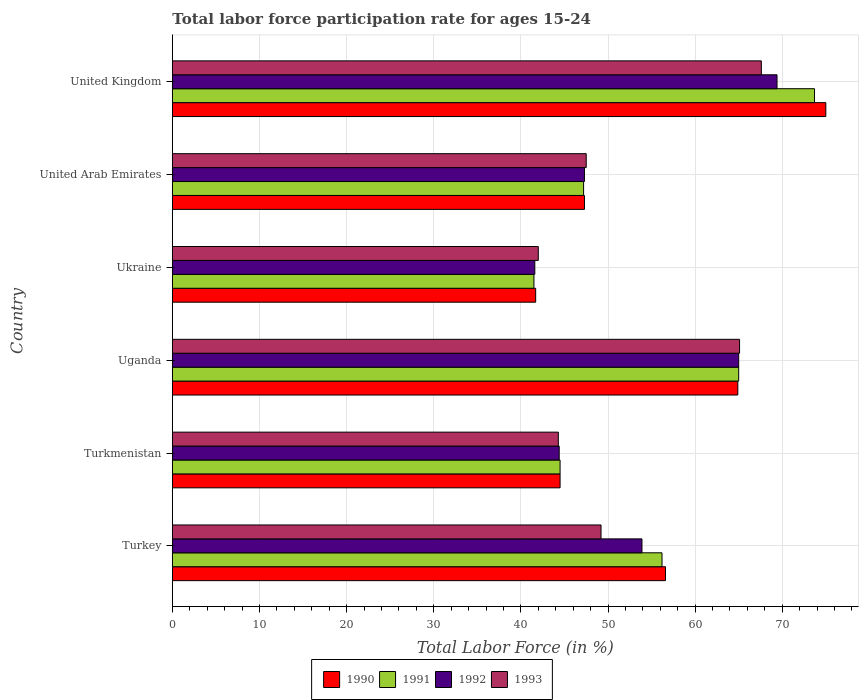How many groups of bars are there?
Your answer should be very brief. 6. Are the number of bars per tick equal to the number of legend labels?
Offer a terse response. Yes. Are the number of bars on each tick of the Y-axis equal?
Offer a terse response. Yes. What is the label of the 4th group of bars from the top?
Offer a very short reply. Uganda. What is the labor force participation rate in 1991 in United Kingdom?
Your answer should be compact. 73.7. Across all countries, what is the maximum labor force participation rate in 1990?
Your answer should be compact. 75. Across all countries, what is the minimum labor force participation rate in 1990?
Offer a very short reply. 41.7. In which country was the labor force participation rate in 1991 maximum?
Your answer should be very brief. United Kingdom. In which country was the labor force participation rate in 1993 minimum?
Your answer should be compact. Ukraine. What is the total labor force participation rate in 1990 in the graph?
Make the answer very short. 330. What is the difference between the labor force participation rate in 1993 in United Arab Emirates and that in United Kingdom?
Provide a succinct answer. -20.1. What is the difference between the labor force participation rate in 1991 in Ukraine and the labor force participation rate in 1992 in Turkey?
Give a very brief answer. -12.4. What is the average labor force participation rate in 1992 per country?
Offer a very short reply. 53.6. What is the difference between the labor force participation rate in 1991 and labor force participation rate in 1993 in Turkey?
Keep it short and to the point. 7. What is the ratio of the labor force participation rate in 1992 in Turkey to that in Turkmenistan?
Your answer should be very brief. 1.21. Is the labor force participation rate in 1992 in Turkmenistan less than that in United Arab Emirates?
Provide a short and direct response. Yes. What is the difference between the highest and the second highest labor force participation rate in 1992?
Make the answer very short. 4.4. What is the difference between the highest and the lowest labor force participation rate in 1991?
Make the answer very short. 32.2. Is the sum of the labor force participation rate in 1991 in Turkey and Turkmenistan greater than the maximum labor force participation rate in 1992 across all countries?
Your response must be concise. Yes. Is it the case that in every country, the sum of the labor force participation rate in 1990 and labor force participation rate in 1992 is greater than the sum of labor force participation rate in 1991 and labor force participation rate in 1993?
Your answer should be compact. No. Are all the bars in the graph horizontal?
Offer a very short reply. Yes. How many countries are there in the graph?
Give a very brief answer. 6. Are the values on the major ticks of X-axis written in scientific E-notation?
Ensure brevity in your answer.  No. Does the graph contain any zero values?
Ensure brevity in your answer.  No. Does the graph contain grids?
Give a very brief answer. Yes. How many legend labels are there?
Keep it short and to the point. 4. What is the title of the graph?
Your response must be concise. Total labor force participation rate for ages 15-24. What is the label or title of the X-axis?
Your answer should be compact. Total Labor Force (in %). What is the label or title of the Y-axis?
Your answer should be very brief. Country. What is the Total Labor Force (in %) in 1990 in Turkey?
Keep it short and to the point. 56.6. What is the Total Labor Force (in %) of 1991 in Turkey?
Keep it short and to the point. 56.2. What is the Total Labor Force (in %) in 1992 in Turkey?
Offer a very short reply. 53.9. What is the Total Labor Force (in %) in 1993 in Turkey?
Provide a short and direct response. 49.2. What is the Total Labor Force (in %) in 1990 in Turkmenistan?
Make the answer very short. 44.5. What is the Total Labor Force (in %) in 1991 in Turkmenistan?
Provide a short and direct response. 44.5. What is the Total Labor Force (in %) of 1992 in Turkmenistan?
Make the answer very short. 44.4. What is the Total Labor Force (in %) in 1993 in Turkmenistan?
Your answer should be very brief. 44.3. What is the Total Labor Force (in %) of 1990 in Uganda?
Offer a very short reply. 64.9. What is the Total Labor Force (in %) of 1993 in Uganda?
Your answer should be compact. 65.1. What is the Total Labor Force (in %) in 1990 in Ukraine?
Your response must be concise. 41.7. What is the Total Labor Force (in %) of 1991 in Ukraine?
Your answer should be very brief. 41.5. What is the Total Labor Force (in %) of 1992 in Ukraine?
Ensure brevity in your answer.  41.6. What is the Total Labor Force (in %) of 1990 in United Arab Emirates?
Your answer should be compact. 47.3. What is the Total Labor Force (in %) in 1991 in United Arab Emirates?
Offer a very short reply. 47.2. What is the Total Labor Force (in %) in 1992 in United Arab Emirates?
Keep it short and to the point. 47.3. What is the Total Labor Force (in %) in 1993 in United Arab Emirates?
Ensure brevity in your answer.  47.5. What is the Total Labor Force (in %) of 1990 in United Kingdom?
Keep it short and to the point. 75. What is the Total Labor Force (in %) of 1991 in United Kingdom?
Your response must be concise. 73.7. What is the Total Labor Force (in %) of 1992 in United Kingdom?
Provide a succinct answer. 69.4. What is the Total Labor Force (in %) in 1993 in United Kingdom?
Your answer should be very brief. 67.6. Across all countries, what is the maximum Total Labor Force (in %) in 1990?
Make the answer very short. 75. Across all countries, what is the maximum Total Labor Force (in %) of 1991?
Your answer should be compact. 73.7. Across all countries, what is the maximum Total Labor Force (in %) in 1992?
Keep it short and to the point. 69.4. Across all countries, what is the maximum Total Labor Force (in %) of 1993?
Keep it short and to the point. 67.6. Across all countries, what is the minimum Total Labor Force (in %) of 1990?
Provide a succinct answer. 41.7. Across all countries, what is the minimum Total Labor Force (in %) of 1991?
Provide a short and direct response. 41.5. Across all countries, what is the minimum Total Labor Force (in %) in 1992?
Offer a terse response. 41.6. Across all countries, what is the minimum Total Labor Force (in %) in 1993?
Offer a very short reply. 42. What is the total Total Labor Force (in %) of 1990 in the graph?
Your answer should be very brief. 330. What is the total Total Labor Force (in %) of 1991 in the graph?
Ensure brevity in your answer.  328.1. What is the total Total Labor Force (in %) of 1992 in the graph?
Your response must be concise. 321.6. What is the total Total Labor Force (in %) in 1993 in the graph?
Offer a terse response. 315.7. What is the difference between the Total Labor Force (in %) in 1990 in Turkey and that in Turkmenistan?
Keep it short and to the point. 12.1. What is the difference between the Total Labor Force (in %) in 1992 in Turkey and that in Turkmenistan?
Offer a very short reply. 9.5. What is the difference between the Total Labor Force (in %) of 1990 in Turkey and that in Uganda?
Offer a terse response. -8.3. What is the difference between the Total Labor Force (in %) of 1991 in Turkey and that in Uganda?
Give a very brief answer. -8.8. What is the difference between the Total Labor Force (in %) of 1993 in Turkey and that in Uganda?
Offer a terse response. -15.9. What is the difference between the Total Labor Force (in %) in 1990 in Turkey and that in Ukraine?
Offer a very short reply. 14.9. What is the difference between the Total Labor Force (in %) of 1990 in Turkey and that in United Arab Emirates?
Your answer should be very brief. 9.3. What is the difference between the Total Labor Force (in %) of 1991 in Turkey and that in United Arab Emirates?
Give a very brief answer. 9. What is the difference between the Total Labor Force (in %) of 1992 in Turkey and that in United Arab Emirates?
Keep it short and to the point. 6.6. What is the difference between the Total Labor Force (in %) of 1990 in Turkey and that in United Kingdom?
Give a very brief answer. -18.4. What is the difference between the Total Labor Force (in %) in 1991 in Turkey and that in United Kingdom?
Offer a terse response. -17.5. What is the difference between the Total Labor Force (in %) in 1992 in Turkey and that in United Kingdom?
Provide a succinct answer. -15.5. What is the difference between the Total Labor Force (in %) in 1993 in Turkey and that in United Kingdom?
Ensure brevity in your answer.  -18.4. What is the difference between the Total Labor Force (in %) of 1990 in Turkmenistan and that in Uganda?
Make the answer very short. -20.4. What is the difference between the Total Labor Force (in %) of 1991 in Turkmenistan and that in Uganda?
Your answer should be very brief. -20.5. What is the difference between the Total Labor Force (in %) of 1992 in Turkmenistan and that in Uganda?
Make the answer very short. -20.6. What is the difference between the Total Labor Force (in %) in 1993 in Turkmenistan and that in Uganda?
Offer a very short reply. -20.8. What is the difference between the Total Labor Force (in %) in 1990 in Turkmenistan and that in Ukraine?
Offer a terse response. 2.8. What is the difference between the Total Labor Force (in %) in 1991 in Turkmenistan and that in Ukraine?
Your answer should be compact. 3. What is the difference between the Total Labor Force (in %) of 1993 in Turkmenistan and that in Ukraine?
Keep it short and to the point. 2.3. What is the difference between the Total Labor Force (in %) of 1991 in Turkmenistan and that in United Arab Emirates?
Make the answer very short. -2.7. What is the difference between the Total Labor Force (in %) in 1992 in Turkmenistan and that in United Arab Emirates?
Give a very brief answer. -2.9. What is the difference between the Total Labor Force (in %) of 1990 in Turkmenistan and that in United Kingdom?
Make the answer very short. -30.5. What is the difference between the Total Labor Force (in %) of 1991 in Turkmenistan and that in United Kingdom?
Give a very brief answer. -29.2. What is the difference between the Total Labor Force (in %) in 1992 in Turkmenistan and that in United Kingdom?
Your answer should be compact. -25. What is the difference between the Total Labor Force (in %) in 1993 in Turkmenistan and that in United Kingdom?
Offer a terse response. -23.3. What is the difference between the Total Labor Force (in %) in 1990 in Uganda and that in Ukraine?
Ensure brevity in your answer.  23.2. What is the difference between the Total Labor Force (in %) in 1992 in Uganda and that in Ukraine?
Offer a very short reply. 23.4. What is the difference between the Total Labor Force (in %) of 1993 in Uganda and that in Ukraine?
Your response must be concise. 23.1. What is the difference between the Total Labor Force (in %) in 1990 in Uganda and that in United Kingdom?
Provide a succinct answer. -10.1. What is the difference between the Total Labor Force (in %) in 1991 in Uganda and that in United Kingdom?
Give a very brief answer. -8.7. What is the difference between the Total Labor Force (in %) in 1990 in Ukraine and that in United Arab Emirates?
Provide a succinct answer. -5.6. What is the difference between the Total Labor Force (in %) of 1990 in Ukraine and that in United Kingdom?
Offer a terse response. -33.3. What is the difference between the Total Labor Force (in %) in 1991 in Ukraine and that in United Kingdom?
Provide a short and direct response. -32.2. What is the difference between the Total Labor Force (in %) in 1992 in Ukraine and that in United Kingdom?
Keep it short and to the point. -27.8. What is the difference between the Total Labor Force (in %) of 1993 in Ukraine and that in United Kingdom?
Make the answer very short. -25.6. What is the difference between the Total Labor Force (in %) in 1990 in United Arab Emirates and that in United Kingdom?
Your answer should be very brief. -27.7. What is the difference between the Total Labor Force (in %) in 1991 in United Arab Emirates and that in United Kingdom?
Ensure brevity in your answer.  -26.5. What is the difference between the Total Labor Force (in %) in 1992 in United Arab Emirates and that in United Kingdom?
Offer a terse response. -22.1. What is the difference between the Total Labor Force (in %) of 1993 in United Arab Emirates and that in United Kingdom?
Offer a very short reply. -20.1. What is the difference between the Total Labor Force (in %) in 1990 in Turkey and the Total Labor Force (in %) in 1991 in Turkmenistan?
Provide a succinct answer. 12.1. What is the difference between the Total Labor Force (in %) of 1990 in Turkey and the Total Labor Force (in %) of 1992 in Turkmenistan?
Offer a terse response. 12.2. What is the difference between the Total Labor Force (in %) in 1992 in Turkey and the Total Labor Force (in %) in 1993 in Turkmenistan?
Give a very brief answer. 9.6. What is the difference between the Total Labor Force (in %) in 1990 in Turkey and the Total Labor Force (in %) in 1991 in Uganda?
Your answer should be very brief. -8.4. What is the difference between the Total Labor Force (in %) in 1990 in Turkey and the Total Labor Force (in %) in 1992 in Uganda?
Your answer should be compact. -8.4. What is the difference between the Total Labor Force (in %) in 1991 in Turkey and the Total Labor Force (in %) in 1992 in Uganda?
Your response must be concise. -8.8. What is the difference between the Total Labor Force (in %) of 1991 in Turkey and the Total Labor Force (in %) of 1993 in Ukraine?
Provide a succinct answer. 14.2. What is the difference between the Total Labor Force (in %) of 1992 in Turkey and the Total Labor Force (in %) of 1993 in Ukraine?
Provide a short and direct response. 11.9. What is the difference between the Total Labor Force (in %) in 1990 in Turkey and the Total Labor Force (in %) in 1991 in United Arab Emirates?
Ensure brevity in your answer.  9.4. What is the difference between the Total Labor Force (in %) of 1990 in Turkey and the Total Labor Force (in %) of 1993 in United Arab Emirates?
Make the answer very short. 9.1. What is the difference between the Total Labor Force (in %) in 1992 in Turkey and the Total Labor Force (in %) in 1993 in United Arab Emirates?
Offer a very short reply. 6.4. What is the difference between the Total Labor Force (in %) in 1990 in Turkey and the Total Labor Force (in %) in 1991 in United Kingdom?
Your response must be concise. -17.1. What is the difference between the Total Labor Force (in %) of 1990 in Turkey and the Total Labor Force (in %) of 1992 in United Kingdom?
Your response must be concise. -12.8. What is the difference between the Total Labor Force (in %) in 1990 in Turkey and the Total Labor Force (in %) in 1993 in United Kingdom?
Provide a succinct answer. -11. What is the difference between the Total Labor Force (in %) of 1991 in Turkey and the Total Labor Force (in %) of 1992 in United Kingdom?
Offer a terse response. -13.2. What is the difference between the Total Labor Force (in %) of 1992 in Turkey and the Total Labor Force (in %) of 1993 in United Kingdom?
Offer a terse response. -13.7. What is the difference between the Total Labor Force (in %) of 1990 in Turkmenistan and the Total Labor Force (in %) of 1991 in Uganda?
Provide a short and direct response. -20.5. What is the difference between the Total Labor Force (in %) in 1990 in Turkmenistan and the Total Labor Force (in %) in 1992 in Uganda?
Offer a terse response. -20.5. What is the difference between the Total Labor Force (in %) in 1990 in Turkmenistan and the Total Labor Force (in %) in 1993 in Uganda?
Make the answer very short. -20.6. What is the difference between the Total Labor Force (in %) in 1991 in Turkmenistan and the Total Labor Force (in %) in 1992 in Uganda?
Your answer should be compact. -20.5. What is the difference between the Total Labor Force (in %) of 1991 in Turkmenistan and the Total Labor Force (in %) of 1993 in Uganda?
Your response must be concise. -20.6. What is the difference between the Total Labor Force (in %) in 1992 in Turkmenistan and the Total Labor Force (in %) in 1993 in Uganda?
Ensure brevity in your answer.  -20.7. What is the difference between the Total Labor Force (in %) of 1991 in Turkmenistan and the Total Labor Force (in %) of 1993 in Ukraine?
Provide a succinct answer. 2.5. What is the difference between the Total Labor Force (in %) in 1992 in Turkmenistan and the Total Labor Force (in %) in 1993 in Ukraine?
Provide a succinct answer. 2.4. What is the difference between the Total Labor Force (in %) in 1990 in Turkmenistan and the Total Labor Force (in %) in 1992 in United Arab Emirates?
Ensure brevity in your answer.  -2.8. What is the difference between the Total Labor Force (in %) of 1990 in Turkmenistan and the Total Labor Force (in %) of 1993 in United Arab Emirates?
Provide a short and direct response. -3. What is the difference between the Total Labor Force (in %) of 1991 in Turkmenistan and the Total Labor Force (in %) of 1993 in United Arab Emirates?
Offer a very short reply. -3. What is the difference between the Total Labor Force (in %) of 1990 in Turkmenistan and the Total Labor Force (in %) of 1991 in United Kingdom?
Offer a very short reply. -29.2. What is the difference between the Total Labor Force (in %) in 1990 in Turkmenistan and the Total Labor Force (in %) in 1992 in United Kingdom?
Provide a succinct answer. -24.9. What is the difference between the Total Labor Force (in %) in 1990 in Turkmenistan and the Total Labor Force (in %) in 1993 in United Kingdom?
Offer a very short reply. -23.1. What is the difference between the Total Labor Force (in %) in 1991 in Turkmenistan and the Total Labor Force (in %) in 1992 in United Kingdom?
Offer a terse response. -24.9. What is the difference between the Total Labor Force (in %) in 1991 in Turkmenistan and the Total Labor Force (in %) in 1993 in United Kingdom?
Offer a terse response. -23.1. What is the difference between the Total Labor Force (in %) of 1992 in Turkmenistan and the Total Labor Force (in %) of 1993 in United Kingdom?
Your response must be concise. -23.2. What is the difference between the Total Labor Force (in %) of 1990 in Uganda and the Total Labor Force (in %) of 1991 in Ukraine?
Keep it short and to the point. 23.4. What is the difference between the Total Labor Force (in %) of 1990 in Uganda and the Total Labor Force (in %) of 1992 in Ukraine?
Your answer should be compact. 23.3. What is the difference between the Total Labor Force (in %) of 1990 in Uganda and the Total Labor Force (in %) of 1993 in Ukraine?
Make the answer very short. 22.9. What is the difference between the Total Labor Force (in %) in 1991 in Uganda and the Total Labor Force (in %) in 1992 in Ukraine?
Your response must be concise. 23.4. What is the difference between the Total Labor Force (in %) of 1992 in Uganda and the Total Labor Force (in %) of 1993 in Ukraine?
Offer a terse response. 23. What is the difference between the Total Labor Force (in %) in 1990 in Uganda and the Total Labor Force (in %) in 1991 in United Arab Emirates?
Keep it short and to the point. 17.7. What is the difference between the Total Labor Force (in %) of 1990 in Uganda and the Total Labor Force (in %) of 1992 in United Arab Emirates?
Keep it short and to the point. 17.6. What is the difference between the Total Labor Force (in %) in 1990 in Uganda and the Total Labor Force (in %) in 1993 in United Arab Emirates?
Offer a very short reply. 17.4. What is the difference between the Total Labor Force (in %) of 1991 in Uganda and the Total Labor Force (in %) of 1993 in United Arab Emirates?
Give a very brief answer. 17.5. What is the difference between the Total Labor Force (in %) in 1992 in Uganda and the Total Labor Force (in %) in 1993 in United Arab Emirates?
Make the answer very short. 17.5. What is the difference between the Total Labor Force (in %) in 1990 in Uganda and the Total Labor Force (in %) in 1991 in United Kingdom?
Your answer should be very brief. -8.8. What is the difference between the Total Labor Force (in %) in 1991 in Uganda and the Total Labor Force (in %) in 1992 in United Kingdom?
Provide a succinct answer. -4.4. What is the difference between the Total Labor Force (in %) of 1990 in Ukraine and the Total Labor Force (in %) of 1991 in United Arab Emirates?
Keep it short and to the point. -5.5. What is the difference between the Total Labor Force (in %) in 1990 in Ukraine and the Total Labor Force (in %) in 1992 in United Arab Emirates?
Offer a very short reply. -5.6. What is the difference between the Total Labor Force (in %) in 1990 in Ukraine and the Total Labor Force (in %) in 1993 in United Arab Emirates?
Ensure brevity in your answer.  -5.8. What is the difference between the Total Labor Force (in %) of 1991 in Ukraine and the Total Labor Force (in %) of 1993 in United Arab Emirates?
Your response must be concise. -6. What is the difference between the Total Labor Force (in %) of 1992 in Ukraine and the Total Labor Force (in %) of 1993 in United Arab Emirates?
Provide a succinct answer. -5.9. What is the difference between the Total Labor Force (in %) of 1990 in Ukraine and the Total Labor Force (in %) of 1991 in United Kingdom?
Give a very brief answer. -32. What is the difference between the Total Labor Force (in %) in 1990 in Ukraine and the Total Labor Force (in %) in 1992 in United Kingdom?
Your answer should be compact. -27.7. What is the difference between the Total Labor Force (in %) of 1990 in Ukraine and the Total Labor Force (in %) of 1993 in United Kingdom?
Keep it short and to the point. -25.9. What is the difference between the Total Labor Force (in %) in 1991 in Ukraine and the Total Labor Force (in %) in 1992 in United Kingdom?
Your answer should be compact. -27.9. What is the difference between the Total Labor Force (in %) in 1991 in Ukraine and the Total Labor Force (in %) in 1993 in United Kingdom?
Give a very brief answer. -26.1. What is the difference between the Total Labor Force (in %) of 1990 in United Arab Emirates and the Total Labor Force (in %) of 1991 in United Kingdom?
Your response must be concise. -26.4. What is the difference between the Total Labor Force (in %) in 1990 in United Arab Emirates and the Total Labor Force (in %) in 1992 in United Kingdom?
Offer a terse response. -22.1. What is the difference between the Total Labor Force (in %) in 1990 in United Arab Emirates and the Total Labor Force (in %) in 1993 in United Kingdom?
Provide a short and direct response. -20.3. What is the difference between the Total Labor Force (in %) of 1991 in United Arab Emirates and the Total Labor Force (in %) of 1992 in United Kingdom?
Offer a very short reply. -22.2. What is the difference between the Total Labor Force (in %) in 1991 in United Arab Emirates and the Total Labor Force (in %) in 1993 in United Kingdom?
Ensure brevity in your answer.  -20.4. What is the difference between the Total Labor Force (in %) of 1992 in United Arab Emirates and the Total Labor Force (in %) of 1993 in United Kingdom?
Your answer should be compact. -20.3. What is the average Total Labor Force (in %) of 1990 per country?
Provide a short and direct response. 55. What is the average Total Labor Force (in %) in 1991 per country?
Give a very brief answer. 54.68. What is the average Total Labor Force (in %) in 1992 per country?
Your response must be concise. 53.6. What is the average Total Labor Force (in %) of 1993 per country?
Ensure brevity in your answer.  52.62. What is the difference between the Total Labor Force (in %) of 1990 and Total Labor Force (in %) of 1991 in Turkey?
Your answer should be very brief. 0.4. What is the difference between the Total Labor Force (in %) of 1990 and Total Labor Force (in %) of 1992 in Turkey?
Offer a very short reply. 2.7. What is the difference between the Total Labor Force (in %) in 1990 and Total Labor Force (in %) in 1993 in Turkey?
Offer a very short reply. 7.4. What is the difference between the Total Labor Force (in %) of 1991 and Total Labor Force (in %) of 1992 in Turkey?
Keep it short and to the point. 2.3. What is the difference between the Total Labor Force (in %) in 1992 and Total Labor Force (in %) in 1993 in Turkey?
Your response must be concise. 4.7. What is the difference between the Total Labor Force (in %) in 1992 and Total Labor Force (in %) in 1993 in Turkmenistan?
Provide a short and direct response. 0.1. What is the difference between the Total Labor Force (in %) in 1990 and Total Labor Force (in %) in 1991 in Uganda?
Ensure brevity in your answer.  -0.1. What is the difference between the Total Labor Force (in %) in 1990 and Total Labor Force (in %) in 1993 in Uganda?
Give a very brief answer. -0.2. What is the difference between the Total Labor Force (in %) in 1991 and Total Labor Force (in %) in 1992 in Uganda?
Your answer should be compact. 0. What is the difference between the Total Labor Force (in %) in 1992 and Total Labor Force (in %) in 1993 in Uganda?
Offer a very short reply. -0.1. What is the difference between the Total Labor Force (in %) in 1990 and Total Labor Force (in %) in 1991 in Ukraine?
Make the answer very short. 0.2. What is the difference between the Total Labor Force (in %) of 1990 and Total Labor Force (in %) of 1992 in Ukraine?
Your response must be concise. 0.1. What is the difference between the Total Labor Force (in %) of 1991 and Total Labor Force (in %) of 1993 in Ukraine?
Ensure brevity in your answer.  -0.5. What is the difference between the Total Labor Force (in %) in 1990 and Total Labor Force (in %) in 1991 in United Arab Emirates?
Make the answer very short. 0.1. What is the difference between the Total Labor Force (in %) in 1990 and Total Labor Force (in %) in 1993 in United Arab Emirates?
Your answer should be very brief. -0.2. What is the difference between the Total Labor Force (in %) in 1990 and Total Labor Force (in %) in 1993 in United Kingdom?
Keep it short and to the point. 7.4. What is the difference between the Total Labor Force (in %) in 1991 and Total Labor Force (in %) in 1992 in United Kingdom?
Your answer should be very brief. 4.3. What is the difference between the Total Labor Force (in %) in 1992 and Total Labor Force (in %) in 1993 in United Kingdom?
Offer a very short reply. 1.8. What is the ratio of the Total Labor Force (in %) of 1990 in Turkey to that in Turkmenistan?
Your answer should be compact. 1.27. What is the ratio of the Total Labor Force (in %) of 1991 in Turkey to that in Turkmenistan?
Provide a succinct answer. 1.26. What is the ratio of the Total Labor Force (in %) of 1992 in Turkey to that in Turkmenistan?
Your answer should be very brief. 1.21. What is the ratio of the Total Labor Force (in %) in 1993 in Turkey to that in Turkmenistan?
Your answer should be very brief. 1.11. What is the ratio of the Total Labor Force (in %) in 1990 in Turkey to that in Uganda?
Your answer should be very brief. 0.87. What is the ratio of the Total Labor Force (in %) of 1991 in Turkey to that in Uganda?
Your answer should be compact. 0.86. What is the ratio of the Total Labor Force (in %) of 1992 in Turkey to that in Uganda?
Keep it short and to the point. 0.83. What is the ratio of the Total Labor Force (in %) of 1993 in Turkey to that in Uganda?
Provide a succinct answer. 0.76. What is the ratio of the Total Labor Force (in %) of 1990 in Turkey to that in Ukraine?
Your answer should be very brief. 1.36. What is the ratio of the Total Labor Force (in %) of 1991 in Turkey to that in Ukraine?
Your answer should be compact. 1.35. What is the ratio of the Total Labor Force (in %) of 1992 in Turkey to that in Ukraine?
Provide a succinct answer. 1.3. What is the ratio of the Total Labor Force (in %) of 1993 in Turkey to that in Ukraine?
Provide a succinct answer. 1.17. What is the ratio of the Total Labor Force (in %) in 1990 in Turkey to that in United Arab Emirates?
Offer a terse response. 1.2. What is the ratio of the Total Labor Force (in %) in 1991 in Turkey to that in United Arab Emirates?
Your answer should be very brief. 1.19. What is the ratio of the Total Labor Force (in %) in 1992 in Turkey to that in United Arab Emirates?
Give a very brief answer. 1.14. What is the ratio of the Total Labor Force (in %) in 1993 in Turkey to that in United Arab Emirates?
Your response must be concise. 1.04. What is the ratio of the Total Labor Force (in %) in 1990 in Turkey to that in United Kingdom?
Your answer should be very brief. 0.75. What is the ratio of the Total Labor Force (in %) in 1991 in Turkey to that in United Kingdom?
Keep it short and to the point. 0.76. What is the ratio of the Total Labor Force (in %) in 1992 in Turkey to that in United Kingdom?
Provide a succinct answer. 0.78. What is the ratio of the Total Labor Force (in %) of 1993 in Turkey to that in United Kingdom?
Offer a terse response. 0.73. What is the ratio of the Total Labor Force (in %) of 1990 in Turkmenistan to that in Uganda?
Offer a very short reply. 0.69. What is the ratio of the Total Labor Force (in %) of 1991 in Turkmenistan to that in Uganda?
Provide a succinct answer. 0.68. What is the ratio of the Total Labor Force (in %) of 1992 in Turkmenistan to that in Uganda?
Provide a succinct answer. 0.68. What is the ratio of the Total Labor Force (in %) of 1993 in Turkmenistan to that in Uganda?
Your answer should be very brief. 0.68. What is the ratio of the Total Labor Force (in %) in 1990 in Turkmenistan to that in Ukraine?
Your answer should be very brief. 1.07. What is the ratio of the Total Labor Force (in %) of 1991 in Turkmenistan to that in Ukraine?
Your response must be concise. 1.07. What is the ratio of the Total Labor Force (in %) of 1992 in Turkmenistan to that in Ukraine?
Offer a very short reply. 1.07. What is the ratio of the Total Labor Force (in %) in 1993 in Turkmenistan to that in Ukraine?
Offer a terse response. 1.05. What is the ratio of the Total Labor Force (in %) of 1990 in Turkmenistan to that in United Arab Emirates?
Offer a terse response. 0.94. What is the ratio of the Total Labor Force (in %) of 1991 in Turkmenistan to that in United Arab Emirates?
Offer a terse response. 0.94. What is the ratio of the Total Labor Force (in %) of 1992 in Turkmenistan to that in United Arab Emirates?
Your answer should be compact. 0.94. What is the ratio of the Total Labor Force (in %) in 1993 in Turkmenistan to that in United Arab Emirates?
Your answer should be very brief. 0.93. What is the ratio of the Total Labor Force (in %) in 1990 in Turkmenistan to that in United Kingdom?
Offer a terse response. 0.59. What is the ratio of the Total Labor Force (in %) of 1991 in Turkmenistan to that in United Kingdom?
Provide a short and direct response. 0.6. What is the ratio of the Total Labor Force (in %) in 1992 in Turkmenistan to that in United Kingdom?
Provide a succinct answer. 0.64. What is the ratio of the Total Labor Force (in %) in 1993 in Turkmenistan to that in United Kingdom?
Ensure brevity in your answer.  0.66. What is the ratio of the Total Labor Force (in %) in 1990 in Uganda to that in Ukraine?
Offer a very short reply. 1.56. What is the ratio of the Total Labor Force (in %) of 1991 in Uganda to that in Ukraine?
Offer a very short reply. 1.57. What is the ratio of the Total Labor Force (in %) of 1992 in Uganda to that in Ukraine?
Make the answer very short. 1.56. What is the ratio of the Total Labor Force (in %) in 1993 in Uganda to that in Ukraine?
Offer a very short reply. 1.55. What is the ratio of the Total Labor Force (in %) in 1990 in Uganda to that in United Arab Emirates?
Make the answer very short. 1.37. What is the ratio of the Total Labor Force (in %) of 1991 in Uganda to that in United Arab Emirates?
Offer a very short reply. 1.38. What is the ratio of the Total Labor Force (in %) in 1992 in Uganda to that in United Arab Emirates?
Give a very brief answer. 1.37. What is the ratio of the Total Labor Force (in %) in 1993 in Uganda to that in United Arab Emirates?
Offer a terse response. 1.37. What is the ratio of the Total Labor Force (in %) in 1990 in Uganda to that in United Kingdom?
Give a very brief answer. 0.87. What is the ratio of the Total Labor Force (in %) of 1991 in Uganda to that in United Kingdom?
Make the answer very short. 0.88. What is the ratio of the Total Labor Force (in %) in 1992 in Uganda to that in United Kingdom?
Provide a succinct answer. 0.94. What is the ratio of the Total Labor Force (in %) in 1993 in Uganda to that in United Kingdom?
Offer a very short reply. 0.96. What is the ratio of the Total Labor Force (in %) in 1990 in Ukraine to that in United Arab Emirates?
Your response must be concise. 0.88. What is the ratio of the Total Labor Force (in %) in 1991 in Ukraine to that in United Arab Emirates?
Provide a succinct answer. 0.88. What is the ratio of the Total Labor Force (in %) of 1992 in Ukraine to that in United Arab Emirates?
Your answer should be very brief. 0.88. What is the ratio of the Total Labor Force (in %) in 1993 in Ukraine to that in United Arab Emirates?
Keep it short and to the point. 0.88. What is the ratio of the Total Labor Force (in %) of 1990 in Ukraine to that in United Kingdom?
Your answer should be compact. 0.56. What is the ratio of the Total Labor Force (in %) in 1991 in Ukraine to that in United Kingdom?
Provide a succinct answer. 0.56. What is the ratio of the Total Labor Force (in %) of 1992 in Ukraine to that in United Kingdom?
Keep it short and to the point. 0.6. What is the ratio of the Total Labor Force (in %) in 1993 in Ukraine to that in United Kingdom?
Give a very brief answer. 0.62. What is the ratio of the Total Labor Force (in %) in 1990 in United Arab Emirates to that in United Kingdom?
Make the answer very short. 0.63. What is the ratio of the Total Labor Force (in %) in 1991 in United Arab Emirates to that in United Kingdom?
Give a very brief answer. 0.64. What is the ratio of the Total Labor Force (in %) in 1992 in United Arab Emirates to that in United Kingdom?
Provide a succinct answer. 0.68. What is the ratio of the Total Labor Force (in %) of 1993 in United Arab Emirates to that in United Kingdom?
Offer a very short reply. 0.7. What is the difference between the highest and the second highest Total Labor Force (in %) in 1992?
Ensure brevity in your answer.  4.4. What is the difference between the highest and the lowest Total Labor Force (in %) of 1990?
Offer a terse response. 33.3. What is the difference between the highest and the lowest Total Labor Force (in %) in 1991?
Provide a short and direct response. 32.2. What is the difference between the highest and the lowest Total Labor Force (in %) in 1992?
Provide a short and direct response. 27.8. What is the difference between the highest and the lowest Total Labor Force (in %) in 1993?
Offer a very short reply. 25.6. 